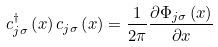Convert formula to latex. <formula><loc_0><loc_0><loc_500><loc_500>c ^ { \dagger } _ { j \sigma } \left ( x \right ) c _ { j \sigma } \left ( x \right ) = \frac { 1 } { 2 \pi } \frac { \partial \Phi _ { j \sigma } \left ( x \right ) } { \partial x }</formula> 